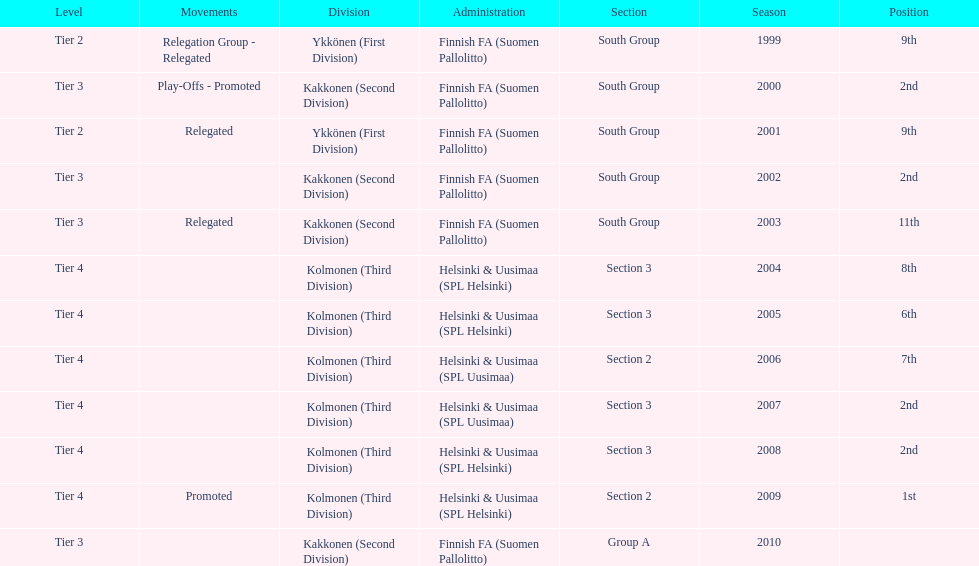Which was the only kolmonen whose movements were promoted? 2009. Would you be able to parse every entry in this table? {'header': ['Level', 'Movements', 'Division', 'Administration', 'Section', 'Season', 'Position'], 'rows': [['Tier 2', 'Relegation Group - Relegated', 'Ykkönen (First Division)', 'Finnish FA (Suomen Pallolitto)', 'South Group', '1999', '9th'], ['Tier 3', 'Play-Offs - Promoted', 'Kakkonen (Second Division)', 'Finnish FA (Suomen Pallolitto)', 'South Group', '2000', '2nd'], ['Tier 2', 'Relegated', 'Ykkönen (First Division)', 'Finnish FA (Suomen Pallolitto)', 'South Group', '2001', '9th'], ['Tier 3', '', 'Kakkonen (Second Division)', 'Finnish FA (Suomen Pallolitto)', 'South Group', '2002', '2nd'], ['Tier 3', 'Relegated', 'Kakkonen (Second Division)', 'Finnish FA (Suomen Pallolitto)', 'South Group', '2003', '11th'], ['Tier 4', '', 'Kolmonen (Third Division)', 'Helsinki & Uusimaa (SPL Helsinki)', 'Section 3', '2004', '8th'], ['Tier 4', '', 'Kolmonen (Third Division)', 'Helsinki & Uusimaa (SPL Helsinki)', 'Section 3', '2005', '6th'], ['Tier 4', '', 'Kolmonen (Third Division)', 'Helsinki & Uusimaa (SPL Uusimaa)', 'Section 2', '2006', '7th'], ['Tier 4', '', 'Kolmonen (Third Division)', 'Helsinki & Uusimaa (SPL Uusimaa)', 'Section 3', '2007', '2nd'], ['Tier 4', '', 'Kolmonen (Third Division)', 'Helsinki & Uusimaa (SPL Helsinki)', 'Section 3', '2008', '2nd'], ['Tier 4', 'Promoted', 'Kolmonen (Third Division)', 'Helsinki & Uusimaa (SPL Helsinki)', 'Section 2', '2009', '1st'], ['Tier 3', '', 'Kakkonen (Second Division)', 'Finnish FA (Suomen Pallolitto)', 'Group A', '2010', '']]} 